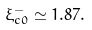Convert formula to latex. <formula><loc_0><loc_0><loc_500><loc_500>\xi _ { c 0 } ^ { - } \simeq 1 . 8 7 \AA .</formula> 